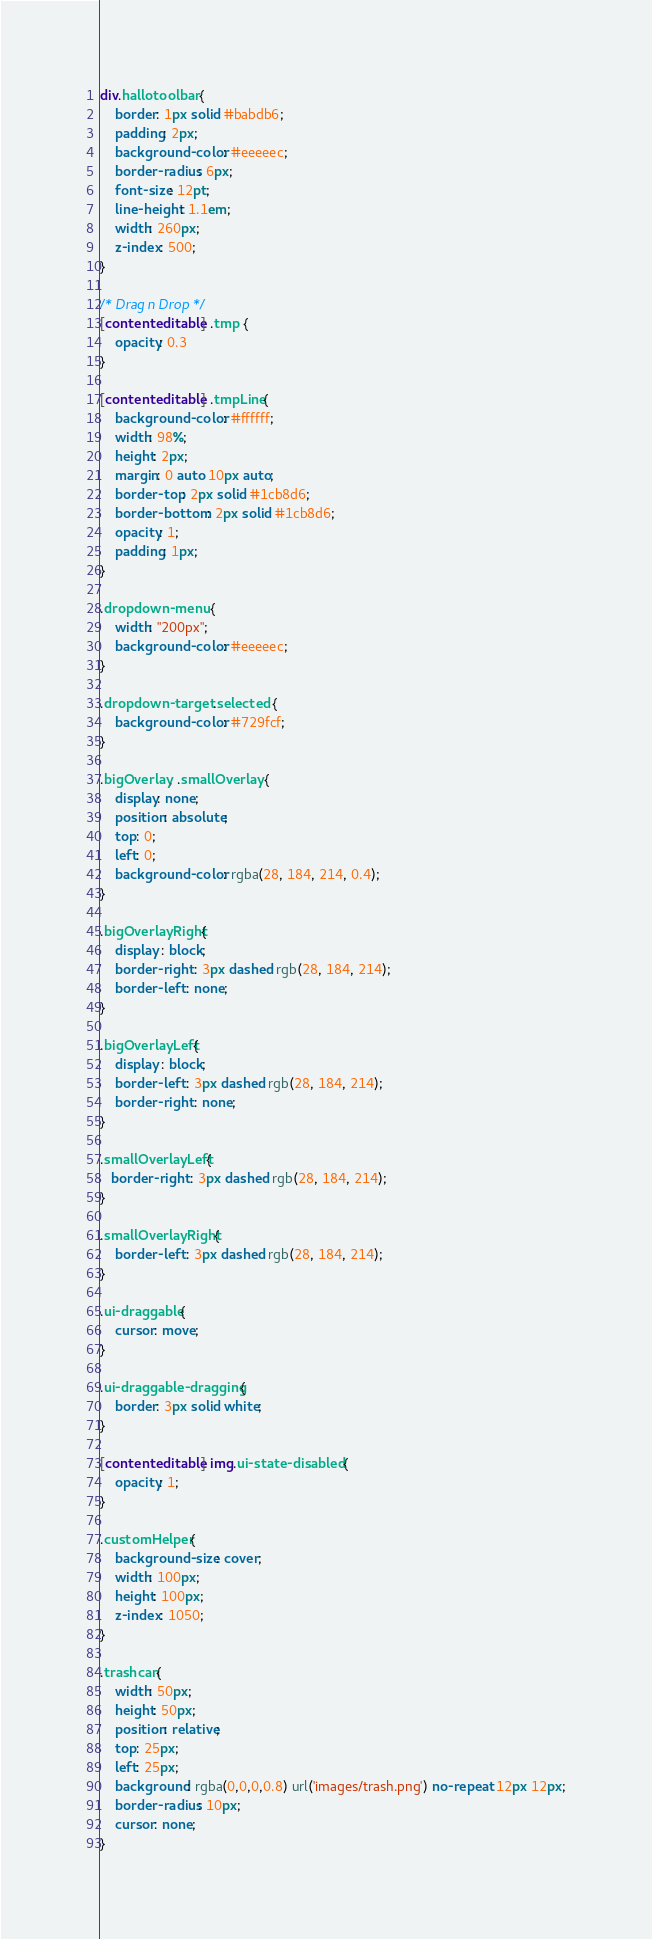<code> <loc_0><loc_0><loc_500><loc_500><_CSS_>div.hallotoolbar {
    border: 1px solid #babdb6;
    padding: 2px;
    background-color: #eeeeec;
    border-radius: 6px;
    font-size: 12pt;
    line-height: 1.1em;
    width: 260px;
    z-index: 500;
}

/* Drag n Drop */
[contenteditable] .tmp {
    opacity: 0.3
}

[contenteditable] .tmpLine{
    background-color: #ffffff;
    width: 98%;
    height: 2px;
    margin: 0 auto 10px auto;
    border-top: 2px solid #1cb8d6;
    border-bottom: 2px solid #1cb8d6;
    opacity: 1;
    padding: 1px;
}

.dropdown-menu {
    width: "200px";
    background-color: #eeeeec;
}

.dropdown-target .selected {
    background-color: #729fcf;
}

.bigOverlay, .smallOverlay {
    display: none;
    position: absolute;
    top: 0;
    left: 0;
    background-color: rgba(28, 184, 214, 0.4);
}

.bigOverlayRight{
    display : block;
    border-right : 3px dashed rgb(28, 184, 214);
    border-left : none;
}

.bigOverlayLeft{
    display : block;
    border-left : 3px dashed rgb(28, 184, 214);
    border-right : none;
}

.smallOverlayLeft{
   border-right : 3px dashed rgb(28, 184, 214);
}

.smallOverlayRight{
    border-left : 3px dashed rgb(28, 184, 214);
}

.ui-draggable{
    cursor: move;
}

.ui-draggable-dragging{
    border: 3px solid white;
}

[contenteditable] img.ui-state-disabled {
    opacity: 1;
}

.customHelper{
    background-size: cover;
    width: 100px;
    height: 100px;
    z-index: 1050;
}

.trashcan{
    width: 50px;
    height: 50px;
    position: relative;
    top: 25px;
    left: 25px;
    background: rgba(0,0,0,0.8) url('images/trash.png') no-repeat 12px 12px;
    border-radius: 10px;
    cursor: none;
}
</code> 